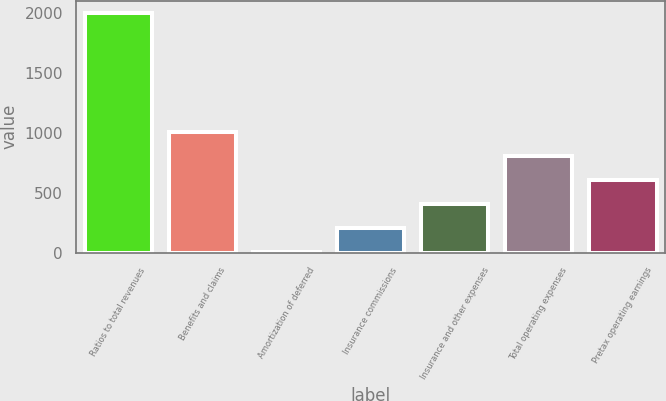Convert chart to OTSL. <chart><loc_0><loc_0><loc_500><loc_500><bar_chart><fcel>Ratios to total revenues<fcel>Benefits and claims<fcel>Amortization of deferred<fcel>Insurance commissions<fcel>Insurance and other expenses<fcel>Total operating expenses<fcel>Pretax operating earnings<nl><fcel>2005<fcel>1006<fcel>7<fcel>206.8<fcel>406.6<fcel>806.2<fcel>606.4<nl></chart> 